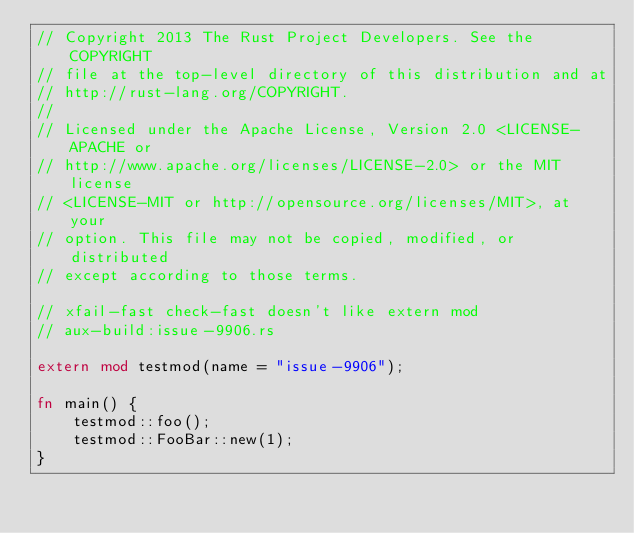<code> <loc_0><loc_0><loc_500><loc_500><_Rust_>// Copyright 2013 The Rust Project Developers. See the COPYRIGHT
// file at the top-level directory of this distribution and at
// http://rust-lang.org/COPYRIGHT.
//
// Licensed under the Apache License, Version 2.0 <LICENSE-APACHE or
// http://www.apache.org/licenses/LICENSE-2.0> or the MIT license
// <LICENSE-MIT or http://opensource.org/licenses/MIT>, at your
// option. This file may not be copied, modified, or distributed
// except according to those terms.

// xfail-fast check-fast doesn't like extern mod
// aux-build:issue-9906.rs

extern mod testmod(name = "issue-9906");

fn main() {
    testmod::foo();
    testmod::FooBar::new(1);
}
</code> 